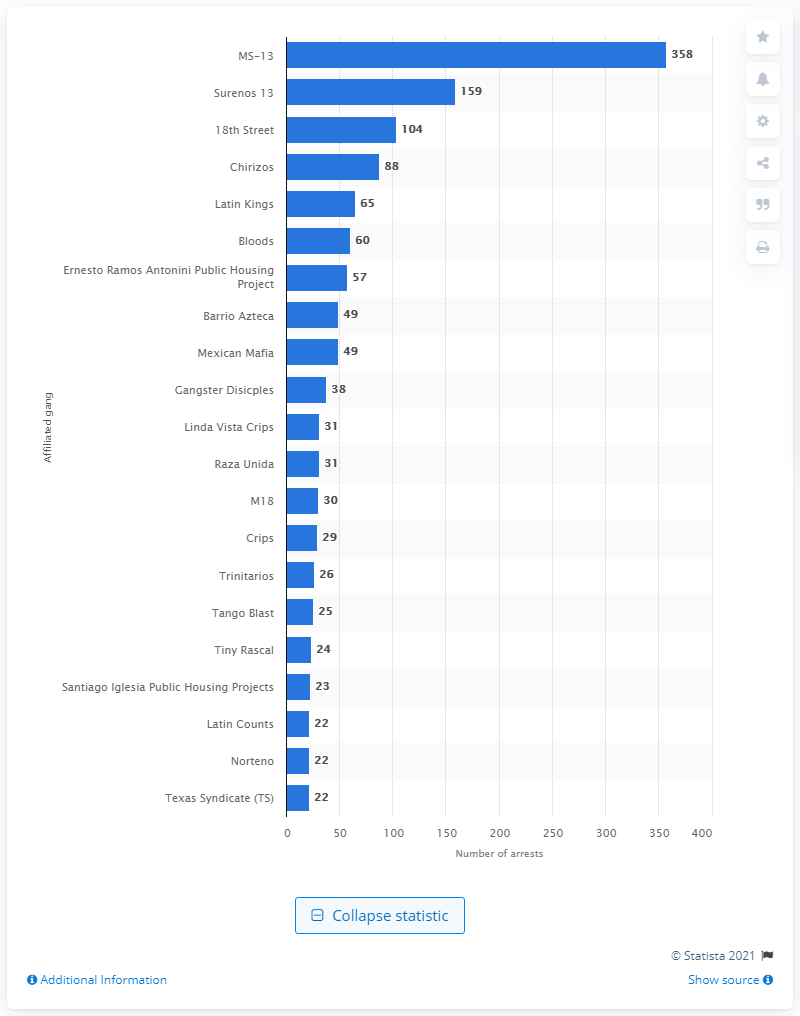Specify some key components in this picture. In 2013, 65 members of the Latin Kings gang were arrested by ICE (Immigration and Customs Enforcement). 